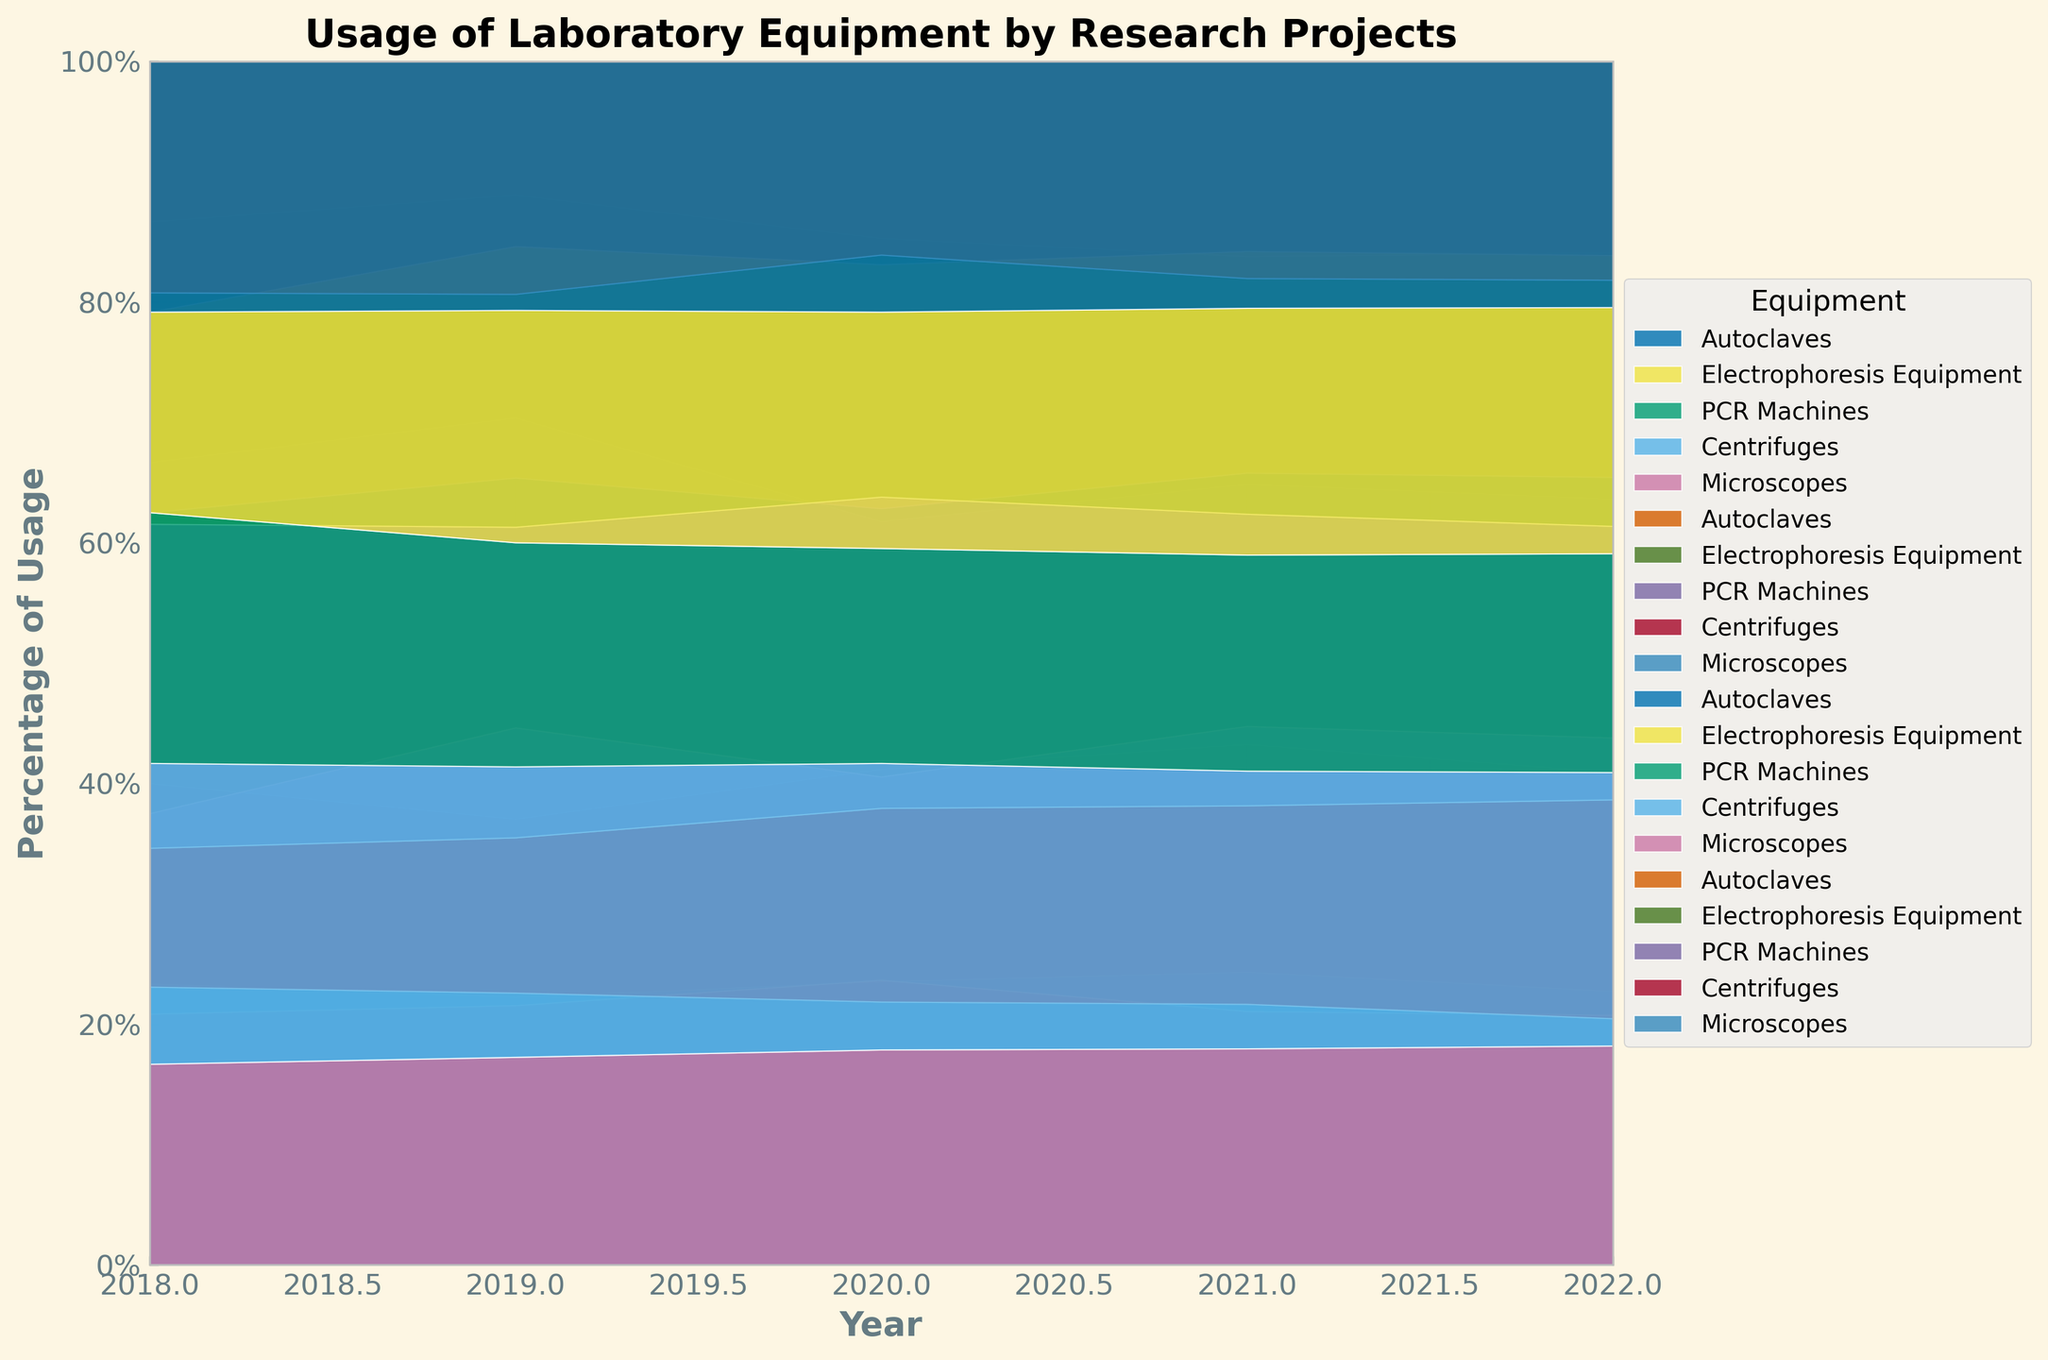How does the usage of PCR Machines change over the five years in the Genomics Research project? The figure shows the trends of equipment usage in the Genomics Research project. For PCR Machines, it starts from around 40% in 2018, increases to 45% in 2019, drops to 35% in 2020, and then returns to 40% in 2021 and finally climbs to 50% in 2022.
Answer: Increases with fluctuations What's the relative usage of Microscopes in the Biotechnology Study project in 2021 compared to 2022? By looking at the 100% stacked area chart, we see that the relative usage of Microscopes in the Biotechnology Study project increased from 2021 to 2022. Specifically, it went from approximately 20% in 2021 to around 25% in 2022.
Answer: Increased What combination of equipment showed consistent usage over the years for the Cancer Research project? Examining the data for Cancer Research over time reveals that the usage percentages for PCR Machines, Centrifuges, and Electrophoresis Equipment remained relatively steady over the years. This can be observed by following the bands corresponding to this equipment.
Answer: PCR Machines, Centrifuges, Electrophoresis Equipment Which project had the highest increase in the usage percentage of Autoclaves from 2018 to 2022? Analyzing the change in the band for Autoclaves from 2018 to 2022 across all projects, the Genomics Research project shows the highest increase in usage percentage for Autoclaves. It increased from around 20% to 35%.
Answer: Genomics Research How does the overall equipment usage trend in the Neuroscience Analysis project compare from 2020 to 2022? Observing the 100% stacked area chart, in the Neuroscience Analysis project, most equipment's relative usage either increased or stayed at similar levels from 2020 to 2022. For example, PCR Machines and Autoclaves both increased, while other equipment also shows slight increases or steadiness.
Answer: Trend is increasing or stable Considering only the year 2022, which piece of equipment had the most uniform usage distribution across all research projects? For 2022, the best way to determine this is to look at how each piece of equipment's band aligns across all projects. Autoclaves seem to have a relatively uniform usage across all research projects as the bands for Autoclaves look similar in height.
Answer: Autoclaves In which year did the Cancer Research project have the maximum usage of Centrifuges, and what was its percentage? From the stacked area chart, the highest usage of Centrifuges in the Cancer Research project occurred in 2022, as the band width for 2022 is the widest and occupies around 22% of the total usage for that year.
Answer: 2022, approximately 22% Among the listed research projects, which one had the least fluctuation in the usage percentage of Electrophoresis Equipment over the years? To identify this, observe the consistency of the band width representing Electrophoresis Equipment across years. Neuroscience Analysis shows the least fluctuation in Electrophoresis Equipment usage as its band remains relatively stable.
Answer: Neuroscience Analysis 